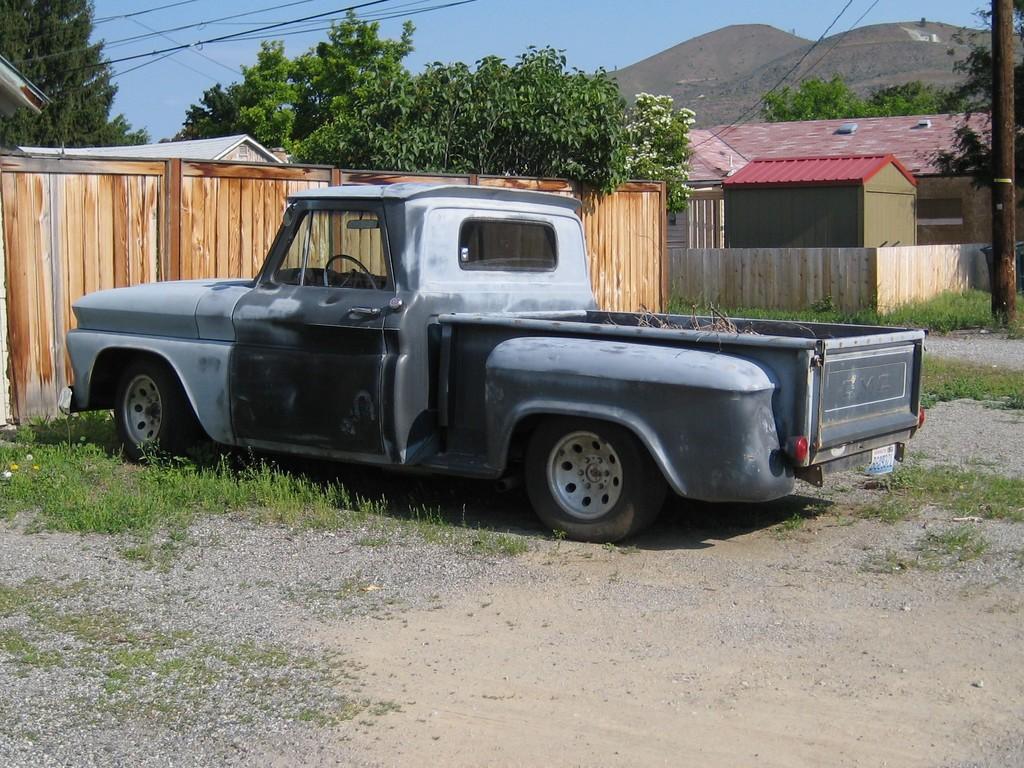Can you describe this image briefly? In this picture we can see a car, beside to the car we can find grass, in the background we can see few houses, cables, trees and a pole. 